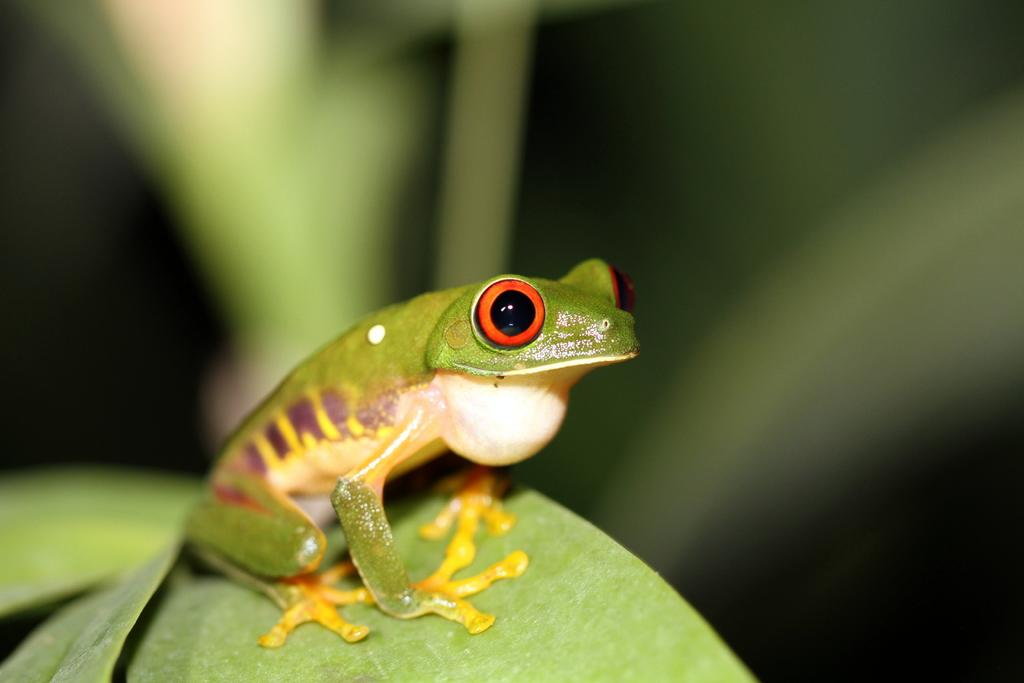What animal is in the picture? There is a frog in the picture. Where is the frog located? The frog is on a leaf. Can you describe the background of the image? The background of the image is blurry. What type of cactus is growing in the background of the image? There is no cactus present in the image; the background is blurry and does not show any specific plants or objects. 